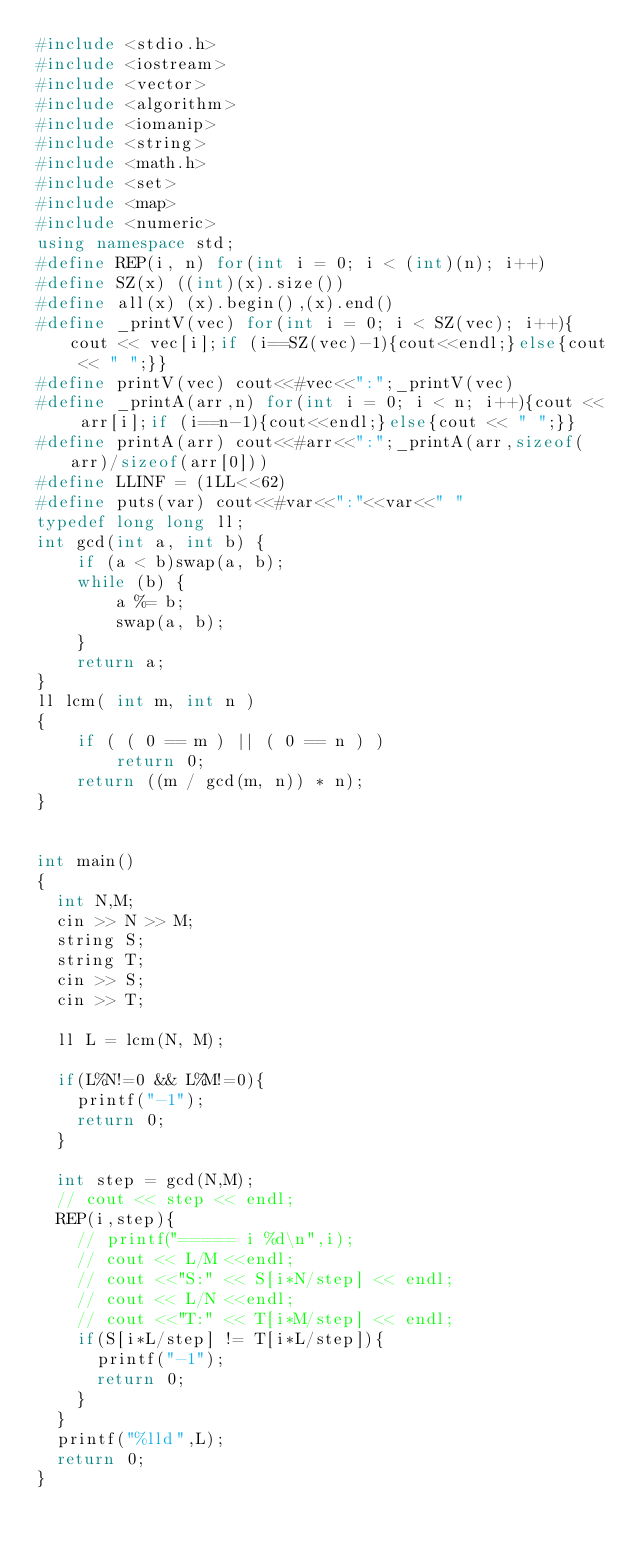<code> <loc_0><loc_0><loc_500><loc_500><_C++_>#include <stdio.h>
#include <iostream>
#include <vector>
#include <algorithm>
#include <iomanip>
#include <string>
#include <math.h>
#include <set>
#include <map>
#include <numeric>
using namespace std;
#define REP(i, n) for(int i = 0; i < (int)(n); i++)
#define SZ(x) ((int)(x).size())
#define all(x) (x).begin(),(x).end()
#define _printV(vec) for(int i = 0; i < SZ(vec); i++){cout << vec[i];if (i==SZ(vec)-1){cout<<endl;}else{cout << " ";}}
#define printV(vec) cout<<#vec<<":";_printV(vec)
#define _printA(arr,n) for(int i = 0; i < n; i++){cout << arr[i];if (i==n-1){cout<<endl;}else{cout << " ";}}
#define printA(arr) cout<<#arr<<":";_printA(arr,sizeof(arr)/sizeof(arr[0]))
#define LLINF = (1LL<<62)
#define puts(var) cout<<#var<<":"<<var<<" "
typedef long long ll;
int gcd(int a, int b) {
	if (a < b)swap(a, b);
	while (b) {
		a %= b;
		swap(a, b);
	}
	return a;
}
ll lcm( int m, int n )
{
	if ( ( 0 == m ) || ( 0 == n ) )
		return 0;
	return ((m / gcd(m, n)) * n);
}


int main()
{
  int N,M;
  cin >> N >> M;
  string S;
  string T;
  cin >> S;
  cin >> T;

  ll L = lcm(N, M);

  if(L%N!=0 && L%M!=0){
    printf("-1");
    return 0;
  }

  int step = gcd(N,M);
  // cout << step << endl;
  REP(i,step){
    // printf("===== i %d\n",i);
    // cout << L/M <<endl;
    // cout <<"S:" << S[i*N/step] << endl;
    // cout << L/N <<endl;
    // cout <<"T:" << T[i*M/step] << endl;
    if(S[i*L/step] != T[i*L/step]){
      printf("-1");
      return 0;
    }
  }
  printf("%lld",L);
  return 0;
}
</code> 